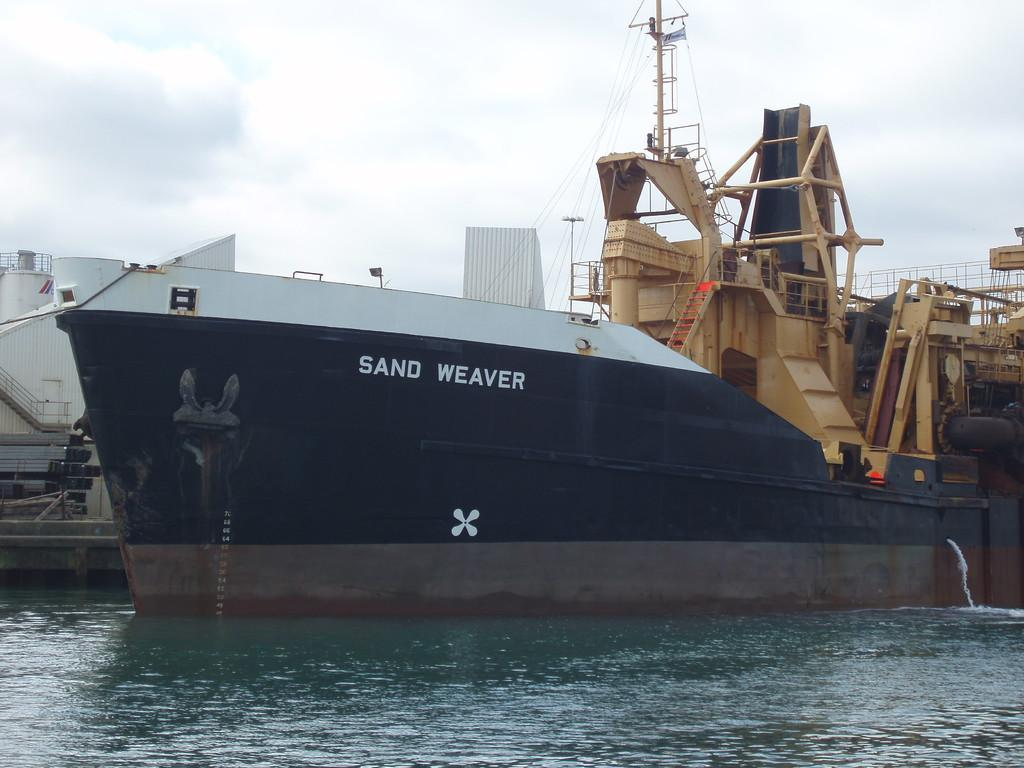Provide a one-sentence caption for the provided image. The black and white boat is named Sand Weaver. 